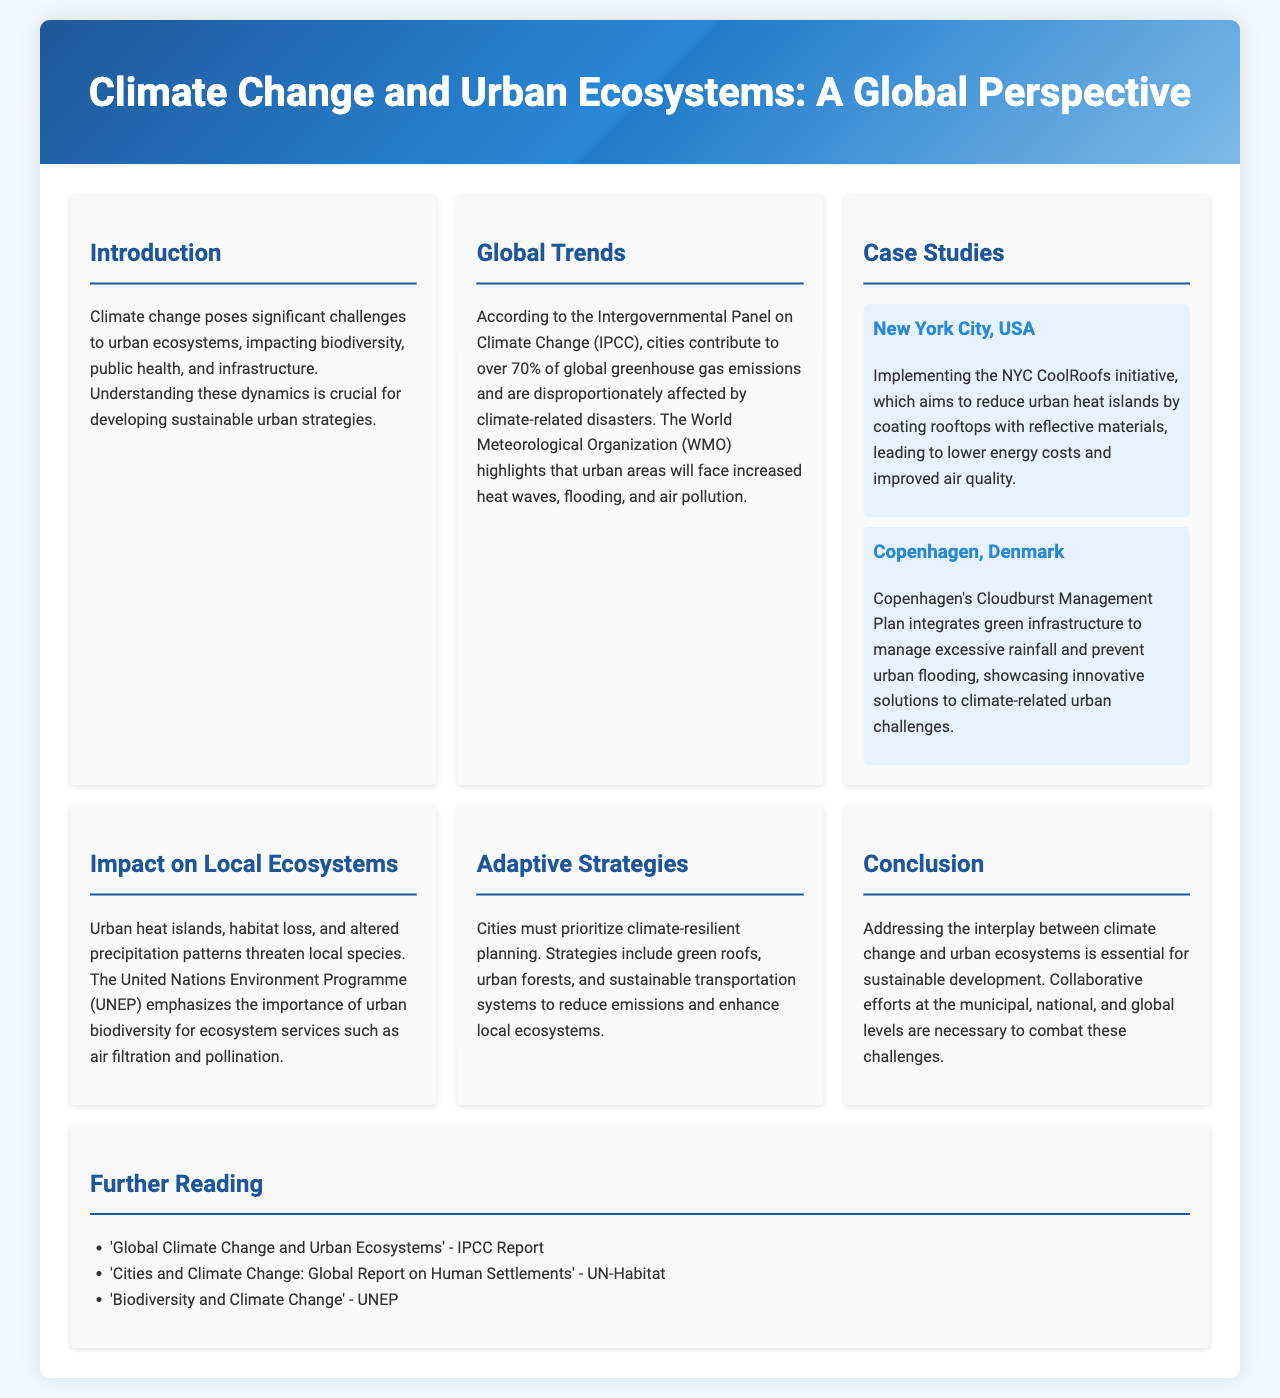What is the title of the brochure? The title of the brochure is mentioned at the top of the document.
Answer: Climate Change and Urban Ecosystems: A Global Perspective Which city implemented the CoolRoofs initiative? The case study section highlights the CoolRoofs initiative specifically in one city.
Answer: New York City, USA What percentage of global greenhouse gas emissions do cities contribute? The global trends section provides a specific statistic regarding emissions from cities.
Answer: Over 70% What are two examples of adaptive strategies mentioned? The adaptive strategies section lists specific sustainable practices relevant to urban planning.
Answer: Green roofs, urban forests What environmental issue is emphasized by UNEP? The impact on local ecosystems section refers to a major concern highlighted by the UNEP.
Answer: Urban biodiversity What is the purpose of Copenhagen's Cloudburst Management Plan? The case study for Copenhagen elaborates on a specific plan's intention regarding urban flooding.
Answer: Manage excessive rainfall What is the main focus of the introduction? The introduction outlines the specific challenges presented by climate change within urban ecosystems.
Answer: Understanding these dynamics is crucial for developing sustainable urban strategies What type of literature is listed under further reading? The further reading section mentions types of reports relevant to the topic discussed in the document.
Answer: Reports 